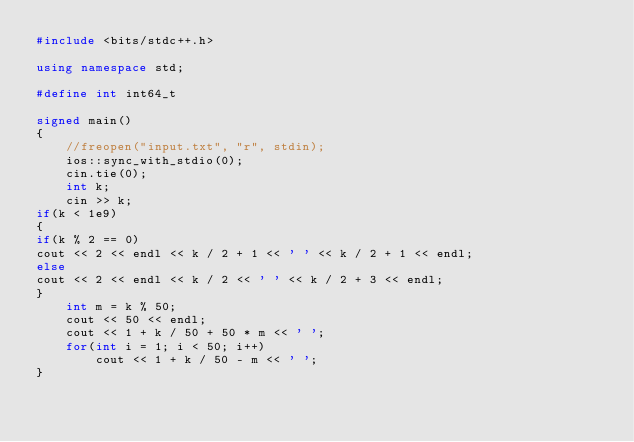<code> <loc_0><loc_0><loc_500><loc_500><_C++_>#include <bits/stdc++.h>

using namespace std;

#define int int64_t

signed main()
{
    //freopen("input.txt", "r", stdin);
    ios::sync_with_stdio(0);
    cin.tie(0);
    int k;
    cin >> k;
if(k < 1e9)
{
if(k % 2 == 0)
cout << 2 << endl << k / 2 + 1 << ' ' << k / 2 + 1 << endl;
else
cout << 2 << endl << k / 2 << ' ' << k / 2 + 3 << endl;
}
    int m = k % 50;
    cout << 50 << endl;
    cout << 1 + k / 50 + 50 * m << ' ';
    for(int i = 1; i < 50; i++)
        cout << 1 + k / 50 - m << ' ';
}
</code> 